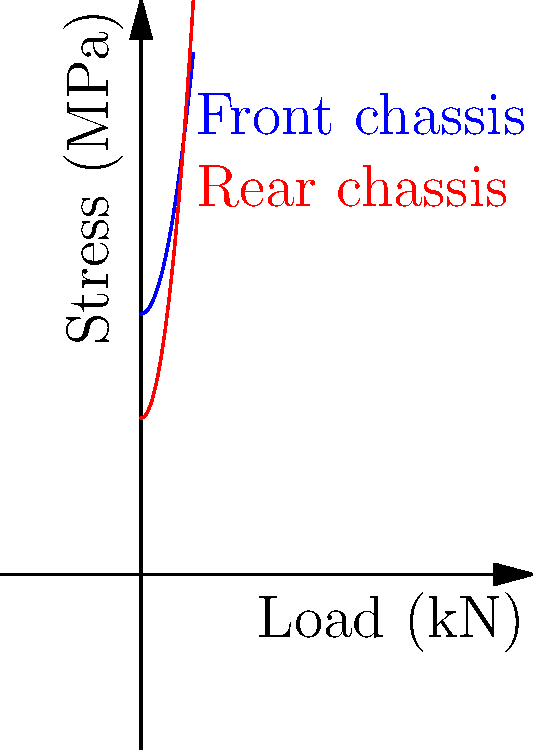As a financial analyst attending a high-end car auction, you're presented with a graph showing stress distribution in a luxury vehicle's chassis under different load conditions. The graph depicts stress (MPa) vs. load (kN) for both front and rear chassis. At what approximate load does the stress in the rear chassis exceed that of the front chassis? To solve this problem, we need to analyze the graph and find the intersection point of the two curves. Let's break it down step-by-step:

1. The blue curve represents the front chassis stress, while the red curve represents the rear chassis stress.

2. The stress in the front chassis is given by the function:
   $$f(x) = 50 + 0.5x^2$$
   where $x$ is the load in kN and $f(x)$ is the stress in MPa.

3. The stress in the rear chassis is given by the function:
   $$g(x) = 30 + 0.8x^2$$

4. To find the intersection point, we need to solve the equation:
   $$50 + 0.5x^2 = 30 + 0.8x^2$$

5. Rearranging the equation:
   $$20 = 0.3x^2$$

6. Solving for $x$:
   $$x^2 = \frac{20}{0.3} \approx 66.67$$
   $$x \approx \sqrt{66.67} \approx 8.16$$

7. Therefore, the rear chassis stress exceeds the front chassis stress at approximately 8.16 kN.

This intersection point represents the load at which the stress distribution in the rear chassis becomes greater than that in the front chassis, which could be crucial information for assessing the vehicle's structural integrity and performance under various driving conditions.
Answer: 8.16 kN 